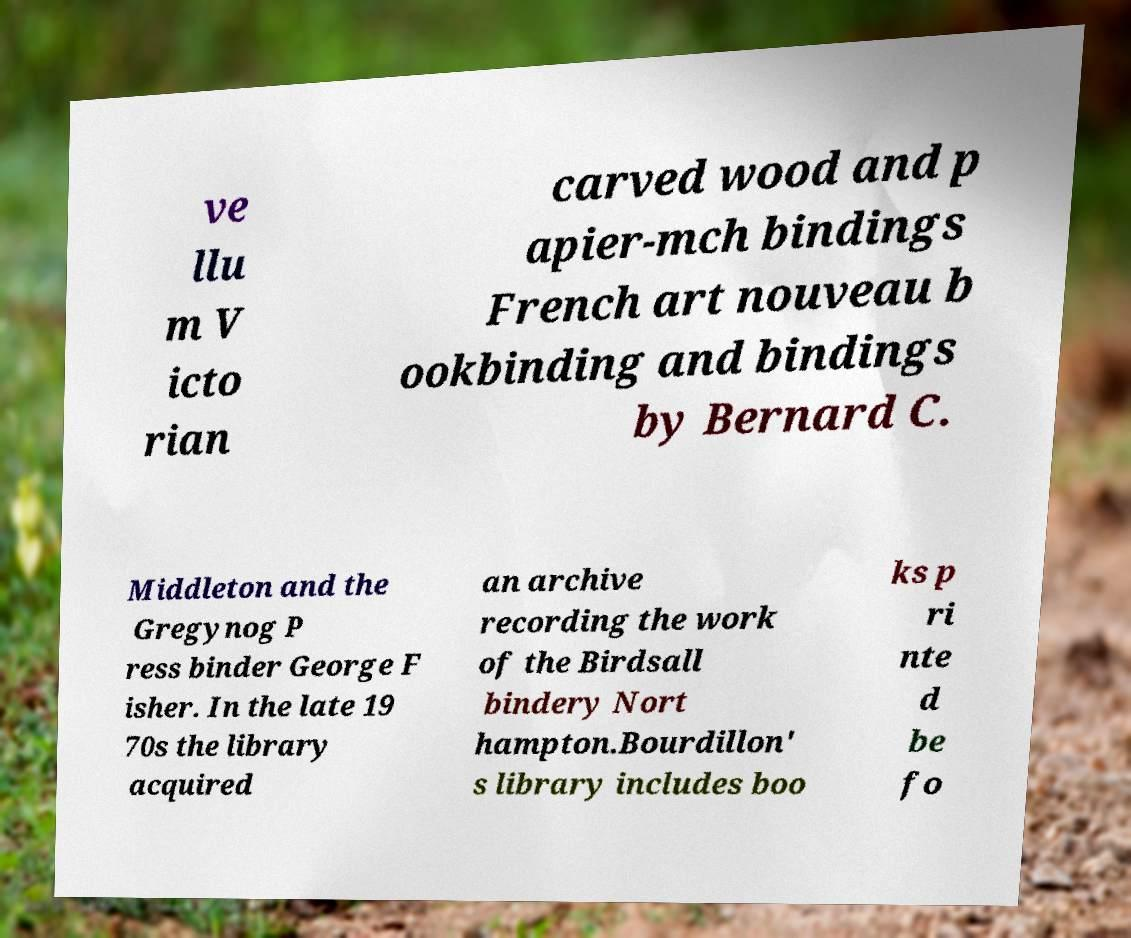Can you read and provide the text displayed in the image?This photo seems to have some interesting text. Can you extract and type it out for me? ve llu m V icto rian carved wood and p apier-mch bindings French art nouveau b ookbinding and bindings by Bernard C. Middleton and the Gregynog P ress binder George F isher. In the late 19 70s the library acquired an archive recording the work of the Birdsall bindery Nort hampton.Bourdillon' s library includes boo ks p ri nte d be fo 